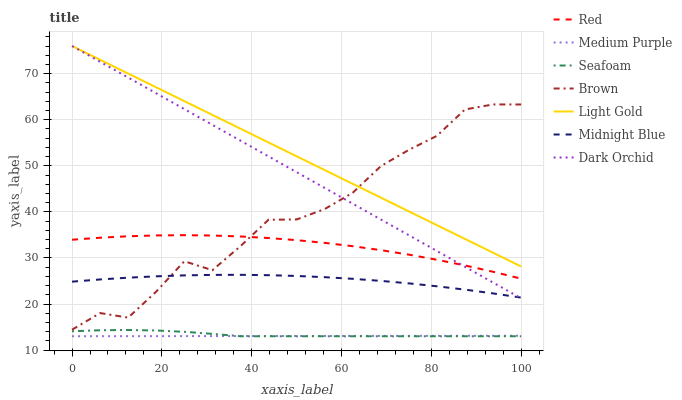Does Medium Purple have the minimum area under the curve?
Answer yes or no. Yes. Does Light Gold have the maximum area under the curve?
Answer yes or no. Yes. Does Midnight Blue have the minimum area under the curve?
Answer yes or no. No. Does Midnight Blue have the maximum area under the curve?
Answer yes or no. No. Is Medium Purple the smoothest?
Answer yes or no. Yes. Is Brown the roughest?
Answer yes or no. Yes. Is Midnight Blue the smoothest?
Answer yes or no. No. Is Midnight Blue the roughest?
Answer yes or no. No. Does Midnight Blue have the lowest value?
Answer yes or no. No. Does Light Gold have the highest value?
Answer yes or no. Yes. Does Midnight Blue have the highest value?
Answer yes or no. No. Is Medium Purple less than Brown?
Answer yes or no. Yes. Is Midnight Blue greater than Medium Purple?
Answer yes or no. Yes. Does Dark Orchid intersect Light Gold?
Answer yes or no. Yes. Is Dark Orchid less than Light Gold?
Answer yes or no. No. Is Dark Orchid greater than Light Gold?
Answer yes or no. No. Does Medium Purple intersect Brown?
Answer yes or no. No. 